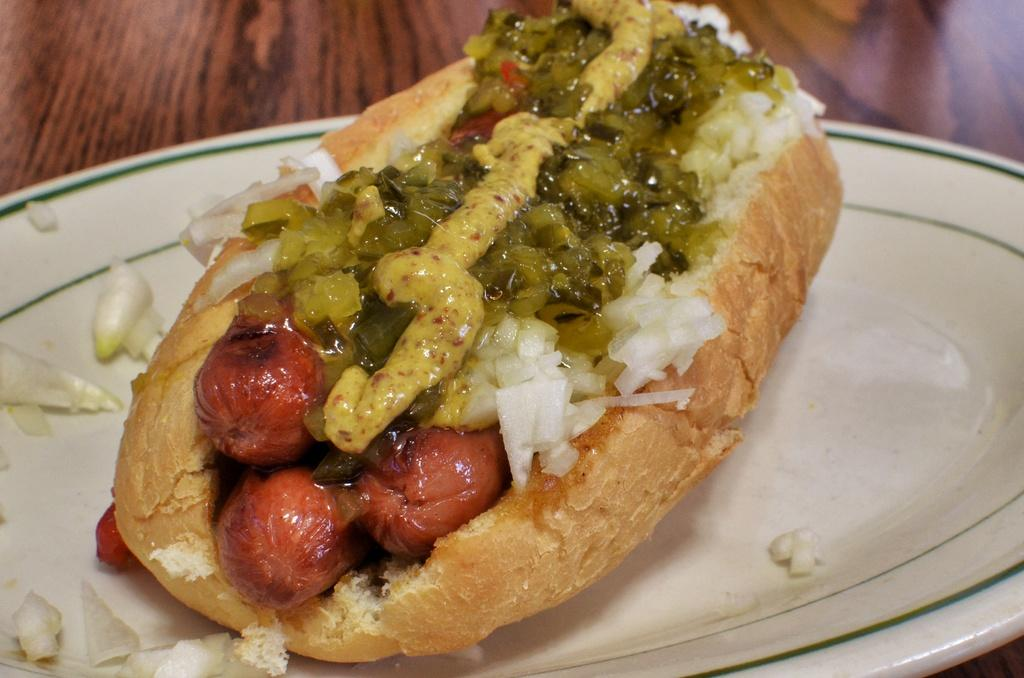What type of food is in the image? There is a hotdog in the image. What toppings are on the hotdog? The hotdog has onions and sauce on it. Where is the hotdog placed? The hotdog is on a plate. What surface is the plate resting on? The plate is over a table. Can you see any agreement or ear in the image? No, there is no agreement or ear present in the image. Is there a nest in the image? No, there is no nest in the image. 